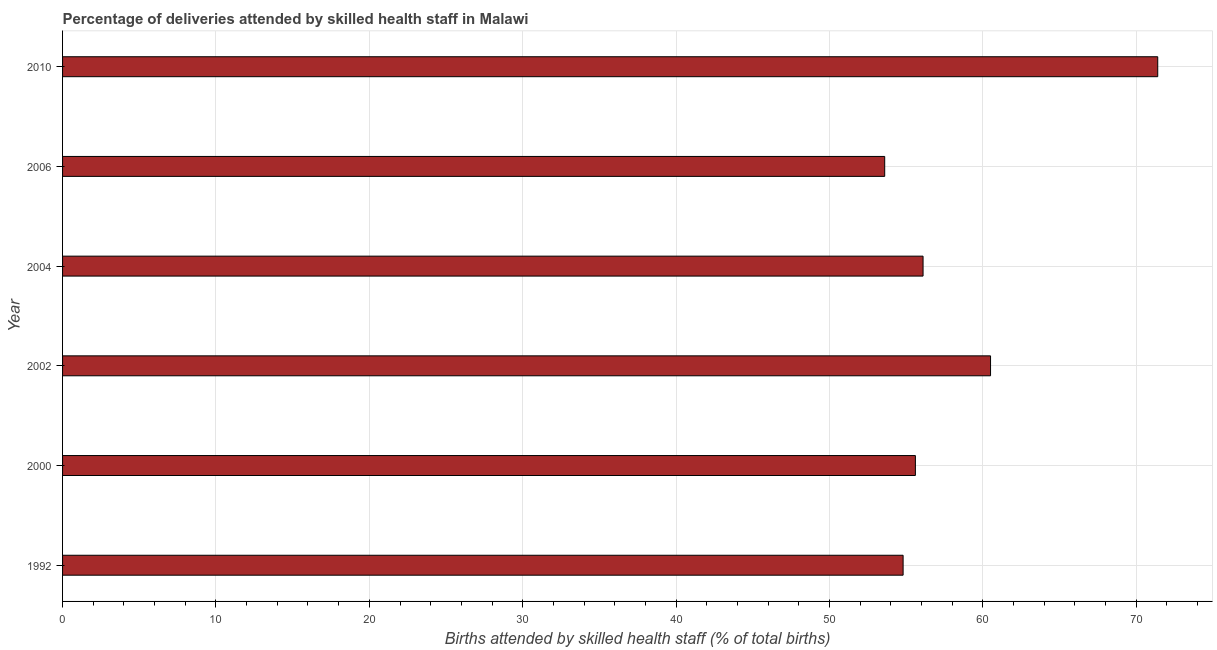Does the graph contain any zero values?
Your response must be concise. No. Does the graph contain grids?
Offer a very short reply. Yes. What is the title of the graph?
Your answer should be compact. Percentage of deliveries attended by skilled health staff in Malawi. What is the label or title of the X-axis?
Your answer should be compact. Births attended by skilled health staff (% of total births). What is the label or title of the Y-axis?
Ensure brevity in your answer.  Year. What is the number of births attended by skilled health staff in 2006?
Keep it short and to the point. 53.6. Across all years, what is the maximum number of births attended by skilled health staff?
Keep it short and to the point. 71.4. Across all years, what is the minimum number of births attended by skilled health staff?
Offer a terse response. 53.6. In which year was the number of births attended by skilled health staff minimum?
Provide a succinct answer. 2006. What is the sum of the number of births attended by skilled health staff?
Ensure brevity in your answer.  352. What is the difference between the number of births attended by skilled health staff in 1992 and 2010?
Give a very brief answer. -16.6. What is the average number of births attended by skilled health staff per year?
Keep it short and to the point. 58.67. What is the median number of births attended by skilled health staff?
Give a very brief answer. 55.85. What is the ratio of the number of births attended by skilled health staff in 1992 to that in 2006?
Ensure brevity in your answer.  1.02. Is the difference between the number of births attended by skilled health staff in 2000 and 2002 greater than the difference between any two years?
Your answer should be very brief. No. What is the difference between the highest and the lowest number of births attended by skilled health staff?
Your answer should be very brief. 17.8. Are all the bars in the graph horizontal?
Keep it short and to the point. Yes. How many years are there in the graph?
Your answer should be very brief. 6. What is the Births attended by skilled health staff (% of total births) in 1992?
Give a very brief answer. 54.8. What is the Births attended by skilled health staff (% of total births) of 2000?
Offer a terse response. 55.6. What is the Births attended by skilled health staff (% of total births) of 2002?
Give a very brief answer. 60.5. What is the Births attended by skilled health staff (% of total births) of 2004?
Ensure brevity in your answer.  56.1. What is the Births attended by skilled health staff (% of total births) in 2006?
Give a very brief answer. 53.6. What is the Births attended by skilled health staff (% of total births) of 2010?
Offer a terse response. 71.4. What is the difference between the Births attended by skilled health staff (% of total births) in 1992 and 2002?
Provide a succinct answer. -5.7. What is the difference between the Births attended by skilled health staff (% of total births) in 1992 and 2004?
Your response must be concise. -1.3. What is the difference between the Births attended by skilled health staff (% of total births) in 1992 and 2010?
Ensure brevity in your answer.  -16.6. What is the difference between the Births attended by skilled health staff (% of total births) in 2000 and 2004?
Your answer should be very brief. -0.5. What is the difference between the Births attended by skilled health staff (% of total births) in 2000 and 2010?
Make the answer very short. -15.8. What is the difference between the Births attended by skilled health staff (% of total births) in 2002 and 2004?
Ensure brevity in your answer.  4.4. What is the difference between the Births attended by skilled health staff (% of total births) in 2002 and 2006?
Provide a short and direct response. 6.9. What is the difference between the Births attended by skilled health staff (% of total births) in 2004 and 2010?
Provide a succinct answer. -15.3. What is the difference between the Births attended by skilled health staff (% of total births) in 2006 and 2010?
Give a very brief answer. -17.8. What is the ratio of the Births attended by skilled health staff (% of total births) in 1992 to that in 2000?
Provide a short and direct response. 0.99. What is the ratio of the Births attended by skilled health staff (% of total births) in 1992 to that in 2002?
Provide a short and direct response. 0.91. What is the ratio of the Births attended by skilled health staff (% of total births) in 1992 to that in 2010?
Your response must be concise. 0.77. What is the ratio of the Births attended by skilled health staff (% of total births) in 2000 to that in 2002?
Offer a very short reply. 0.92. What is the ratio of the Births attended by skilled health staff (% of total births) in 2000 to that in 2004?
Your response must be concise. 0.99. What is the ratio of the Births attended by skilled health staff (% of total births) in 2000 to that in 2006?
Offer a very short reply. 1.04. What is the ratio of the Births attended by skilled health staff (% of total births) in 2000 to that in 2010?
Ensure brevity in your answer.  0.78. What is the ratio of the Births attended by skilled health staff (% of total births) in 2002 to that in 2004?
Your response must be concise. 1.08. What is the ratio of the Births attended by skilled health staff (% of total births) in 2002 to that in 2006?
Offer a very short reply. 1.13. What is the ratio of the Births attended by skilled health staff (% of total births) in 2002 to that in 2010?
Provide a succinct answer. 0.85. What is the ratio of the Births attended by skilled health staff (% of total births) in 2004 to that in 2006?
Provide a succinct answer. 1.05. What is the ratio of the Births attended by skilled health staff (% of total births) in 2004 to that in 2010?
Your answer should be compact. 0.79. What is the ratio of the Births attended by skilled health staff (% of total births) in 2006 to that in 2010?
Provide a succinct answer. 0.75. 